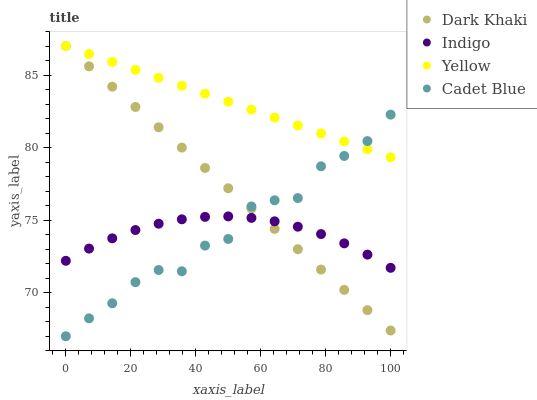Does Indigo have the minimum area under the curve?
Answer yes or no. Yes. Does Yellow have the maximum area under the curve?
Answer yes or no. Yes. Does Cadet Blue have the minimum area under the curve?
Answer yes or no. No. Does Cadet Blue have the maximum area under the curve?
Answer yes or no. No. Is Yellow the smoothest?
Answer yes or no. Yes. Is Cadet Blue the roughest?
Answer yes or no. Yes. Is Indigo the smoothest?
Answer yes or no. No. Is Indigo the roughest?
Answer yes or no. No. Does Cadet Blue have the lowest value?
Answer yes or no. Yes. Does Indigo have the lowest value?
Answer yes or no. No. Does Yellow have the highest value?
Answer yes or no. Yes. Does Cadet Blue have the highest value?
Answer yes or no. No. Is Indigo less than Yellow?
Answer yes or no. Yes. Is Yellow greater than Indigo?
Answer yes or no. Yes. Does Cadet Blue intersect Indigo?
Answer yes or no. Yes. Is Cadet Blue less than Indigo?
Answer yes or no. No. Is Cadet Blue greater than Indigo?
Answer yes or no. No. Does Indigo intersect Yellow?
Answer yes or no. No. 